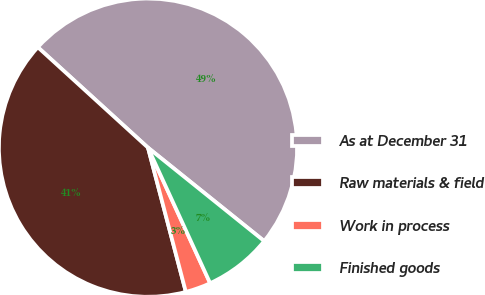<chart> <loc_0><loc_0><loc_500><loc_500><pie_chart><fcel>As at December 31<fcel>Raw materials & field<fcel>Work in process<fcel>Finished goods<nl><fcel>49.01%<fcel>40.85%<fcel>2.76%<fcel>7.38%<nl></chart> 